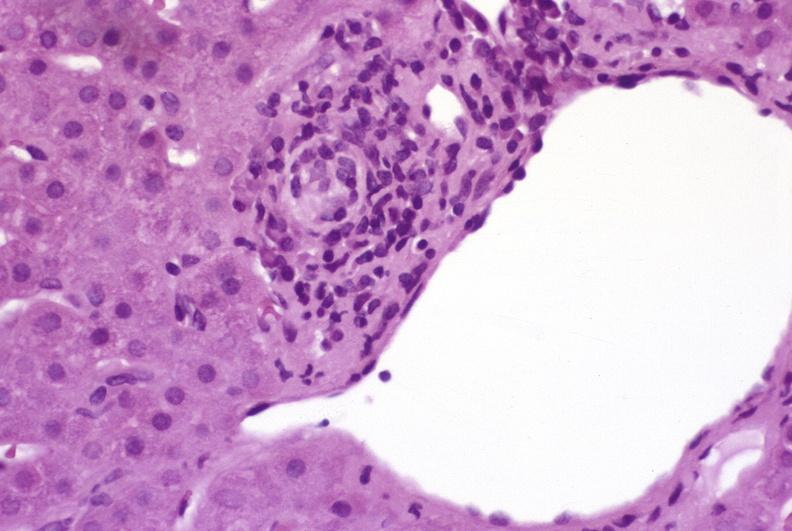s cyst present?
Answer the question using a single word or phrase. No 